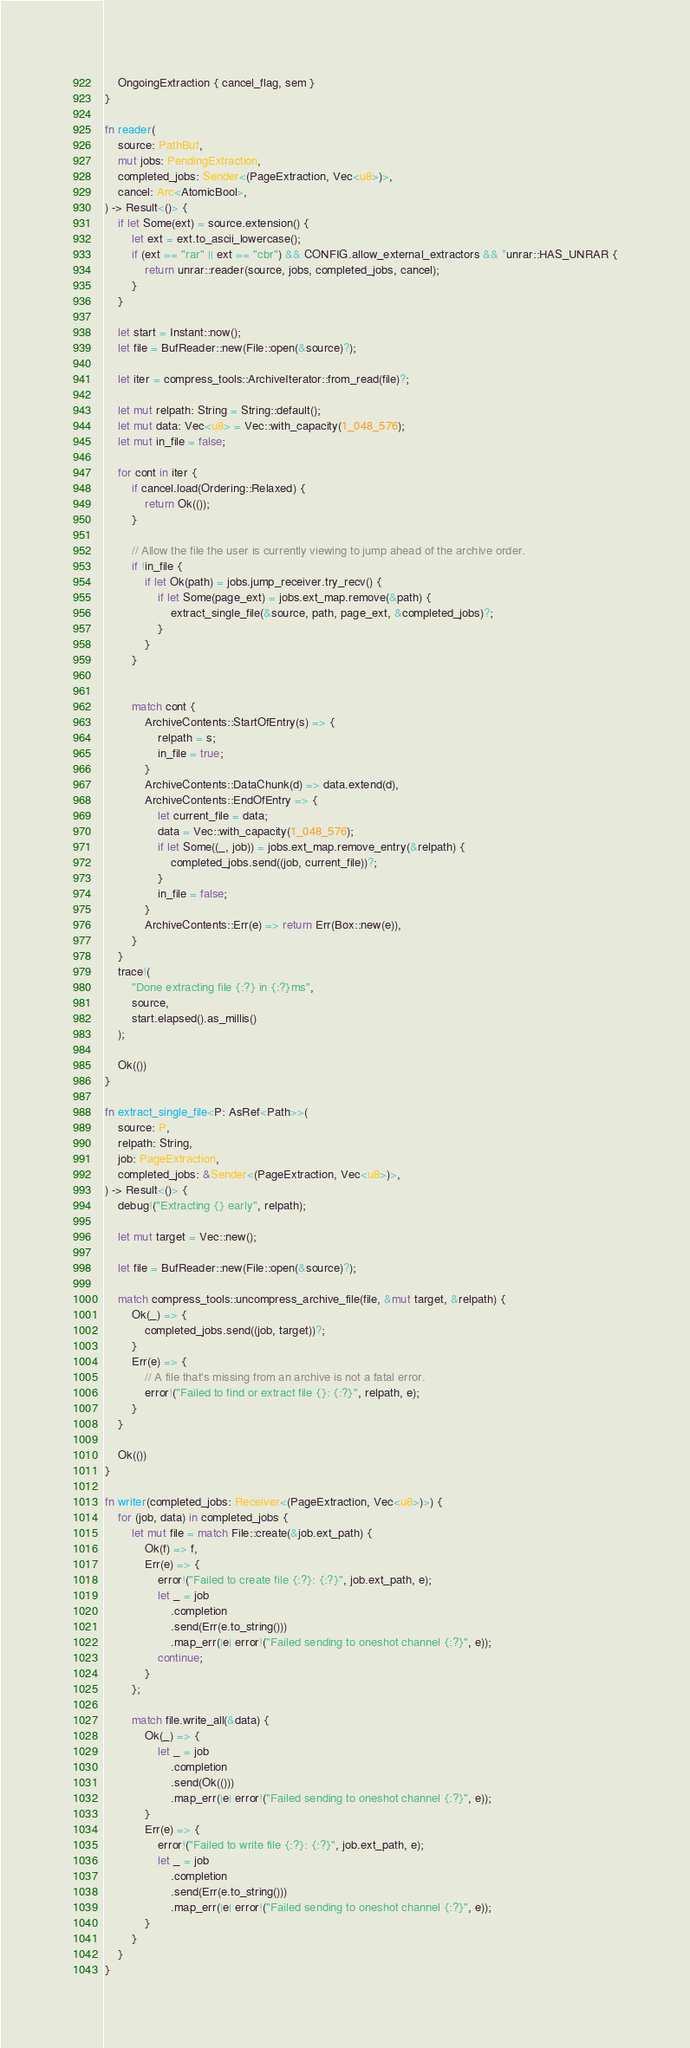Convert code to text. <code><loc_0><loc_0><loc_500><loc_500><_Rust_>    OngoingExtraction { cancel_flag, sem }
}

fn reader(
    source: PathBuf,
    mut jobs: PendingExtraction,
    completed_jobs: Sender<(PageExtraction, Vec<u8>)>,
    cancel: Arc<AtomicBool>,
) -> Result<()> {
    if let Some(ext) = source.extension() {
        let ext = ext.to_ascii_lowercase();
        if (ext == "rar" || ext == "cbr") && CONFIG.allow_external_extractors && *unrar::HAS_UNRAR {
            return unrar::reader(source, jobs, completed_jobs, cancel);
        }
    }

    let start = Instant::now();
    let file = BufReader::new(File::open(&source)?);

    let iter = compress_tools::ArchiveIterator::from_read(file)?;

    let mut relpath: String = String::default();
    let mut data: Vec<u8> = Vec::with_capacity(1_048_576);
    let mut in_file = false;

    for cont in iter {
        if cancel.load(Ordering::Relaxed) {
            return Ok(());
        }

        // Allow the file the user is currently viewing to jump ahead of the archive order.
        if !in_file {
            if let Ok(path) = jobs.jump_receiver.try_recv() {
                if let Some(page_ext) = jobs.ext_map.remove(&path) {
                    extract_single_file(&source, path, page_ext, &completed_jobs)?;
                }
            }
        }


        match cont {
            ArchiveContents::StartOfEntry(s) => {
                relpath = s;
                in_file = true;
            }
            ArchiveContents::DataChunk(d) => data.extend(d),
            ArchiveContents::EndOfEntry => {
                let current_file = data;
                data = Vec::with_capacity(1_048_576);
                if let Some((_, job)) = jobs.ext_map.remove_entry(&relpath) {
                    completed_jobs.send((job, current_file))?;
                }
                in_file = false;
            }
            ArchiveContents::Err(e) => return Err(Box::new(e)),
        }
    }
    trace!(
        "Done extracting file {:?} in {:?}ms",
        source,
        start.elapsed().as_millis()
    );

    Ok(())
}

fn extract_single_file<P: AsRef<Path>>(
    source: P,
    relpath: String,
    job: PageExtraction,
    completed_jobs: &Sender<(PageExtraction, Vec<u8>)>,
) -> Result<()> {
    debug!("Extracting {} early", relpath);

    let mut target = Vec::new();

    let file = BufReader::new(File::open(&source)?);

    match compress_tools::uncompress_archive_file(file, &mut target, &relpath) {
        Ok(_) => {
            completed_jobs.send((job, target))?;
        }
        Err(e) => {
            // A file that's missing from an archive is not a fatal error.
            error!("Failed to find or extract file {}: {:?}", relpath, e);
        }
    }

    Ok(())
}

fn writer(completed_jobs: Receiver<(PageExtraction, Vec<u8>)>) {
    for (job, data) in completed_jobs {
        let mut file = match File::create(&job.ext_path) {
            Ok(f) => f,
            Err(e) => {
                error!("Failed to create file {:?}: {:?}", job.ext_path, e);
                let _ = job
                    .completion
                    .send(Err(e.to_string()))
                    .map_err(|e| error!("Failed sending to oneshot channel {:?}", e));
                continue;
            }
        };

        match file.write_all(&data) {
            Ok(_) => {
                let _ = job
                    .completion
                    .send(Ok(()))
                    .map_err(|e| error!("Failed sending to oneshot channel {:?}", e));
            }
            Err(e) => {
                error!("Failed to write file {:?}: {:?}", job.ext_path, e);
                let _ = job
                    .completion
                    .send(Err(e.to_string()))
                    .map_err(|e| error!("Failed sending to oneshot channel {:?}", e));
            }
        }
    }
}
</code> 